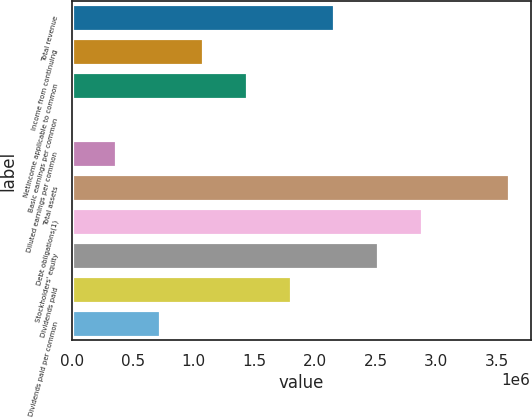<chart> <loc_0><loc_0><loc_500><loc_500><bar_chart><fcel>Total revenue<fcel>Income from continuing<fcel>Netincome applicable to common<fcel>Basic earnings per common<fcel>Diluted earnings per common<fcel>Total assets<fcel>Debt obligations(1)<fcel>Stockholders' equity<fcel>Dividends paid<fcel>Dividends paid per common<nl><fcel>2.15836e+06<fcel>1.07918e+06<fcel>1.43891e+06<fcel>0.7<fcel>359727<fcel>3.59726e+06<fcel>2.87781e+06<fcel>2.51809e+06<fcel>1.79863e+06<fcel>719454<nl></chart> 